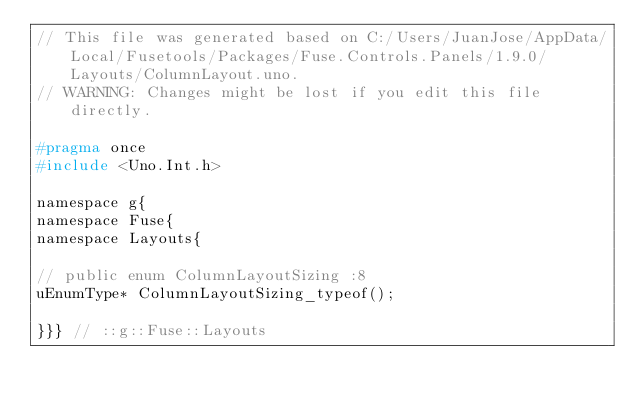Convert code to text. <code><loc_0><loc_0><loc_500><loc_500><_C_>// This file was generated based on C:/Users/JuanJose/AppData/Local/Fusetools/Packages/Fuse.Controls.Panels/1.9.0/Layouts/ColumnLayout.uno.
// WARNING: Changes might be lost if you edit this file directly.

#pragma once
#include <Uno.Int.h>

namespace g{
namespace Fuse{
namespace Layouts{

// public enum ColumnLayoutSizing :8
uEnumType* ColumnLayoutSizing_typeof();

}}} // ::g::Fuse::Layouts
</code> 